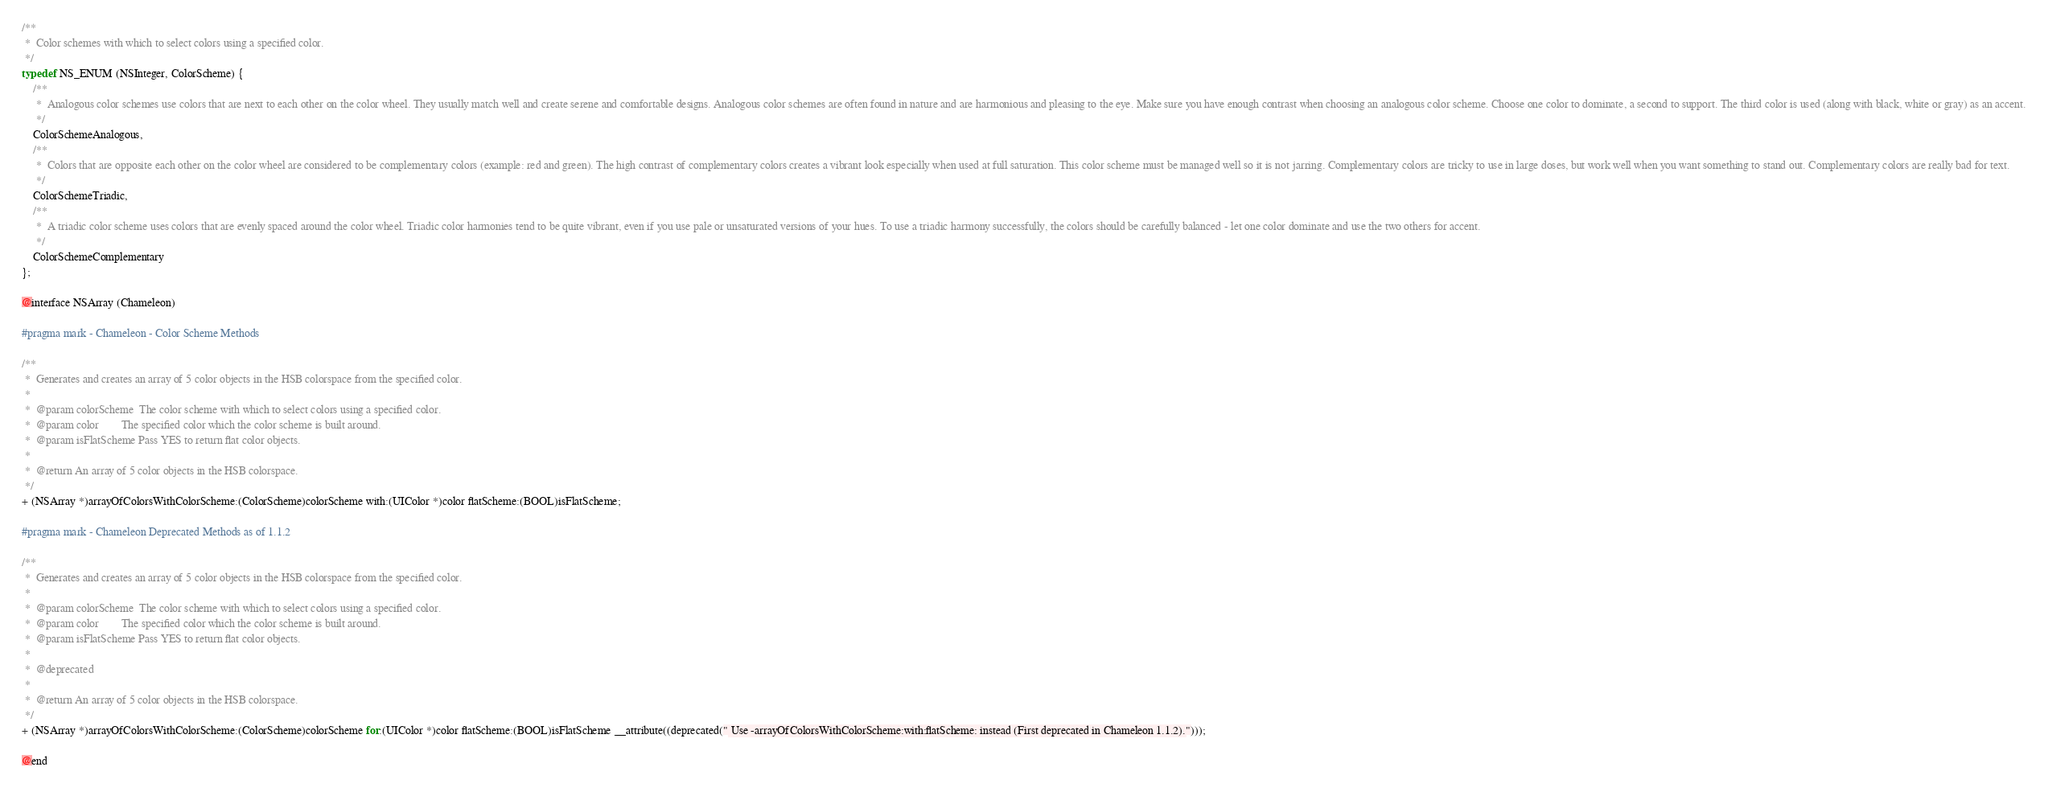Convert code to text. <code><loc_0><loc_0><loc_500><loc_500><_C_>
/**
 *  Color schemes with which to select colors using a specified color.
 */
typedef NS_ENUM (NSInteger, ColorScheme) {
    /**
     *  Analogous color schemes use colors that are next to each other on the color wheel. They usually match well and create serene and comfortable designs. Analogous color schemes are often found in nature and are harmonious and pleasing to the eye. Make sure you have enough contrast when choosing an analogous color scheme. Choose one color to dominate, a second to support. The third color is used (along with black, white or gray) as an accent.
     */
    ColorSchemeAnalogous,
    /**
     *  Colors that are opposite each other on the color wheel are considered to be complementary colors (example: red and green). The high contrast of complementary colors creates a vibrant look especially when used at full saturation. This color scheme must be managed well so it is not jarring. Complementary colors are tricky to use in large doses, but work well when you want something to stand out. Complementary colors are really bad for text.
     */
    ColorSchemeTriadic,
    /**
     *  A triadic color scheme uses colors that are evenly spaced around the color wheel. Triadic color harmonies tend to be quite vibrant, even if you use pale or unsaturated versions of your hues. To use a triadic harmony successfully, the colors should be carefully balanced - let one color dominate and use the two others for accent.
     */
    ColorSchemeComplementary
};

@interface NSArray (Chameleon)

#pragma mark - Chameleon - Color Scheme Methods

/**
 *  Generates and creates an array of 5 color objects in the HSB colorspace from the specified color.
 *
 *  @param colorScheme  The color scheme with which to select colors using a specified color.
 *  @param color        The specified color which the color scheme is built around.
 *  @param isFlatScheme Pass YES to return flat color objects.
 *
 *  @return An array of 5 color objects in the HSB colorspace.
 */
+ (NSArray *)arrayOfColorsWithColorScheme:(ColorScheme)colorScheme with:(UIColor *)color flatScheme:(BOOL)isFlatScheme;

#pragma mark - Chameleon Deprecated Methods as of 1.1.2

/**
 *  Generates and creates an array of 5 color objects in the HSB colorspace from the specified color.
 *
 *  @param colorScheme  The color scheme with which to select colors using a specified color.
 *  @param color        The specified color which the color scheme is built around.
 *  @param isFlatScheme Pass YES to return flat color objects.
 *
 *  @deprecated
 *
 *  @return An array of 5 color objects in the HSB colorspace.
 */
+ (NSArray *)arrayOfColorsWithColorScheme:(ColorScheme)colorScheme for:(UIColor *)color flatScheme:(BOOL)isFlatScheme __attribute((deprecated(" Use -arrayOfColorsWithColorScheme:with:flatScheme: instead (First deprecated in Chameleon 1.1.2).")));

@end
</code> 